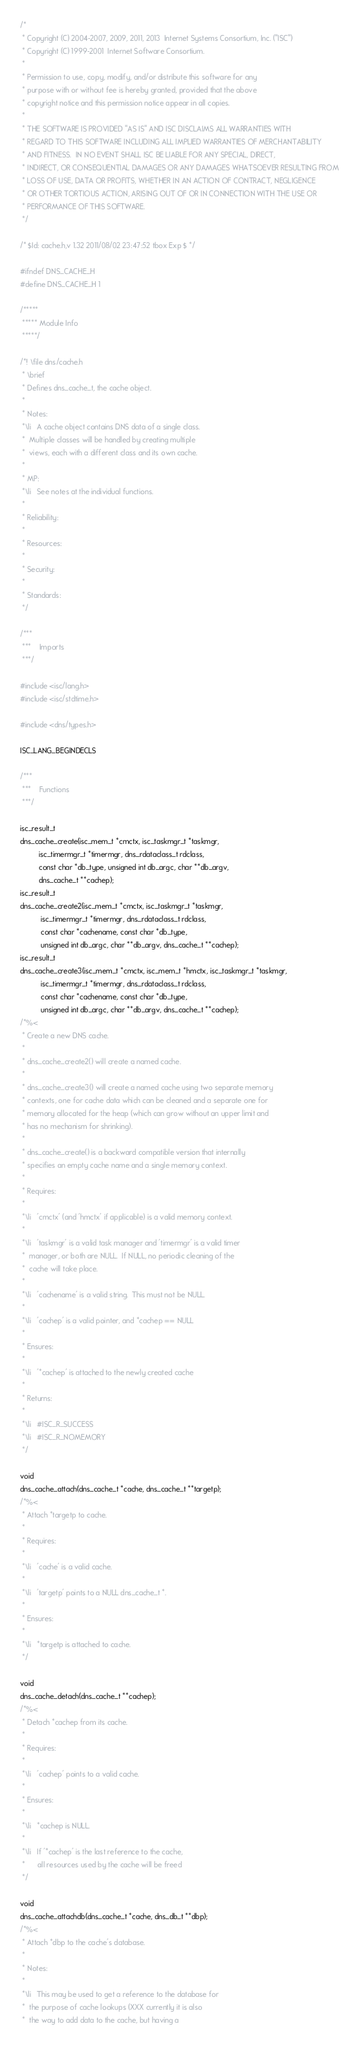<code> <loc_0><loc_0><loc_500><loc_500><_C_>/*
 * Copyright (C) 2004-2007, 2009, 2011, 2013  Internet Systems Consortium, Inc. ("ISC")
 * Copyright (C) 1999-2001  Internet Software Consortium.
 *
 * Permission to use, copy, modify, and/or distribute this software for any
 * purpose with or without fee is hereby granted, provided that the above
 * copyright notice and this permission notice appear in all copies.
 *
 * THE SOFTWARE IS PROVIDED "AS IS" AND ISC DISCLAIMS ALL WARRANTIES WITH
 * REGARD TO THIS SOFTWARE INCLUDING ALL IMPLIED WARRANTIES OF MERCHANTABILITY
 * AND FITNESS.  IN NO EVENT SHALL ISC BE LIABLE FOR ANY SPECIAL, DIRECT,
 * INDIRECT, OR CONSEQUENTIAL DAMAGES OR ANY DAMAGES WHATSOEVER RESULTING FROM
 * LOSS OF USE, DATA OR PROFITS, WHETHER IN AN ACTION OF CONTRACT, NEGLIGENCE
 * OR OTHER TORTIOUS ACTION, ARISING OUT OF OR IN CONNECTION WITH THE USE OR
 * PERFORMANCE OF THIS SOFTWARE.
 */

/* $Id: cache.h,v 1.32 2011/08/02 23:47:52 tbox Exp $ */

#ifndef DNS_CACHE_H
#define DNS_CACHE_H 1

/*****
 ***** Module Info
 *****/

/*! \file dns/cache.h
 * \brief
 * Defines dns_cache_t, the cache object.
 *
 * Notes:
 *\li 	A cache object contains DNS data of a single class.
 *	Multiple classes will be handled by creating multiple
 *	views, each with a different class and its own cache.
 *
 * MP:
 *\li	See notes at the individual functions.
 *
 * Reliability:
 *
 * Resources:
 *
 * Security:
 *
 * Standards:
 */

/***
 ***	Imports
 ***/

#include <isc/lang.h>
#include <isc/stdtime.h>

#include <dns/types.h>

ISC_LANG_BEGINDECLS

/***
 ***	Functions
 ***/

isc_result_t
dns_cache_create(isc_mem_t *cmctx, isc_taskmgr_t *taskmgr,
		 isc_timermgr_t *timermgr, dns_rdataclass_t rdclass,
		 const char *db_type, unsigned int db_argc, char **db_argv,
		 dns_cache_t **cachep);
isc_result_t
dns_cache_create2(isc_mem_t *cmctx, isc_taskmgr_t *taskmgr,
		  isc_timermgr_t *timermgr, dns_rdataclass_t rdclass,
		  const char *cachename, const char *db_type,
		  unsigned int db_argc, char **db_argv, dns_cache_t **cachep);
isc_result_t
dns_cache_create3(isc_mem_t *cmctx, isc_mem_t *hmctx, isc_taskmgr_t *taskmgr,
		  isc_timermgr_t *timermgr, dns_rdataclass_t rdclass,
		  const char *cachename, const char *db_type,
		  unsigned int db_argc, char **db_argv, dns_cache_t **cachep);
/*%<
 * Create a new DNS cache.
 *
 * dns_cache_create2() will create a named cache.
 *
 * dns_cache_create3() will create a named cache using two separate memory
 * contexts, one for cache data which can be cleaned and a separate one for
 * memory allocated for the heap (which can grow without an upper limit and
 * has no mechanism for shrinking).
 *
 * dns_cache_create() is a backward compatible version that internally
 * specifies an empty cache name and a single memory context.
 *
 * Requires:
 *
 *\li	'cmctx' (and 'hmctx' if applicable) is a valid memory context.
 *
 *\li	'taskmgr' is a valid task manager and 'timermgr' is a valid timer
 * 	manager, or both are NULL.  If NULL, no periodic cleaning of the
 * 	cache will take place.
 *
 *\li	'cachename' is a valid string.  This must not be NULL.
 *
 *\li	'cachep' is a valid pointer, and *cachep == NULL
 *
 * Ensures:
 *
 *\li	'*cachep' is attached to the newly created cache
 *
 * Returns:
 *
 *\li	#ISC_R_SUCCESS
 *\li	#ISC_R_NOMEMORY
 */

void
dns_cache_attach(dns_cache_t *cache, dns_cache_t **targetp);
/*%<
 * Attach *targetp to cache.
 *
 * Requires:
 *
 *\li	'cache' is a valid cache.
 *
 *\li	'targetp' points to a NULL dns_cache_t *.
 *
 * Ensures:
 *
 *\li	*targetp is attached to cache.
 */

void
dns_cache_detach(dns_cache_t **cachep);
/*%<
 * Detach *cachep from its cache.
 *
 * Requires:
 *
 *\li	'cachep' points to a valid cache.
 *
 * Ensures:
 *
 *\li	*cachep is NULL.
 *
 *\li	If '*cachep' is the last reference to the cache,
 *		all resources used by the cache will be freed
 */

void
dns_cache_attachdb(dns_cache_t *cache, dns_db_t **dbp);
/*%<
 * Attach *dbp to the cache's database.
 *
 * Notes:
 *
 *\li	This may be used to get a reference to the database for
 *	the purpose of cache lookups (XXX currently it is also
 * 	the way to add data to the cache, but having a</code> 